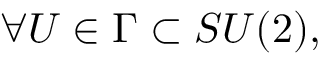Convert formula to latex. <formula><loc_0><loc_0><loc_500><loc_500>\forall U \in \Gamma \subset S U ( 2 ) ,</formula> 